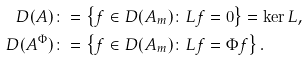Convert formula to latex. <formula><loc_0><loc_0><loc_500><loc_500>D ( A ) \colon & = \left \{ f \in D ( A _ { m } ) \colon L f = 0 \right \} = \ker L , \\ D ( A ^ { \Phi } ) \colon & = \left \{ f \in D ( A _ { m } ) \colon L f = \Phi f \right \} .</formula> 